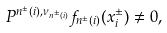Convert formula to latex. <formula><loc_0><loc_0><loc_500><loc_500>P ^ { n ^ { \pm } ( i ) , \nu _ { n ^ { \pm } ( i ) } } f _ { n ^ { \pm } ( i ) } ( x ^ { \pm } _ { i } ) \ne 0 ,</formula> 